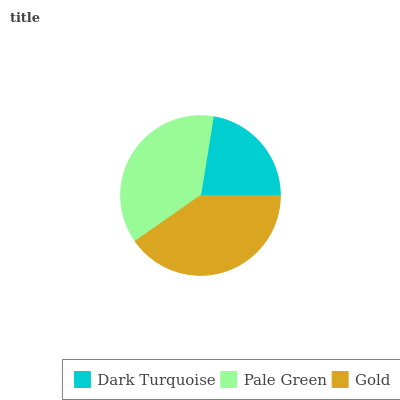Is Dark Turquoise the minimum?
Answer yes or no. Yes. Is Gold the maximum?
Answer yes or no. Yes. Is Pale Green the minimum?
Answer yes or no. No. Is Pale Green the maximum?
Answer yes or no. No. Is Pale Green greater than Dark Turquoise?
Answer yes or no. Yes. Is Dark Turquoise less than Pale Green?
Answer yes or no. Yes. Is Dark Turquoise greater than Pale Green?
Answer yes or no. No. Is Pale Green less than Dark Turquoise?
Answer yes or no. No. Is Pale Green the high median?
Answer yes or no. Yes. Is Pale Green the low median?
Answer yes or no. Yes. Is Gold the high median?
Answer yes or no. No. Is Gold the low median?
Answer yes or no. No. 